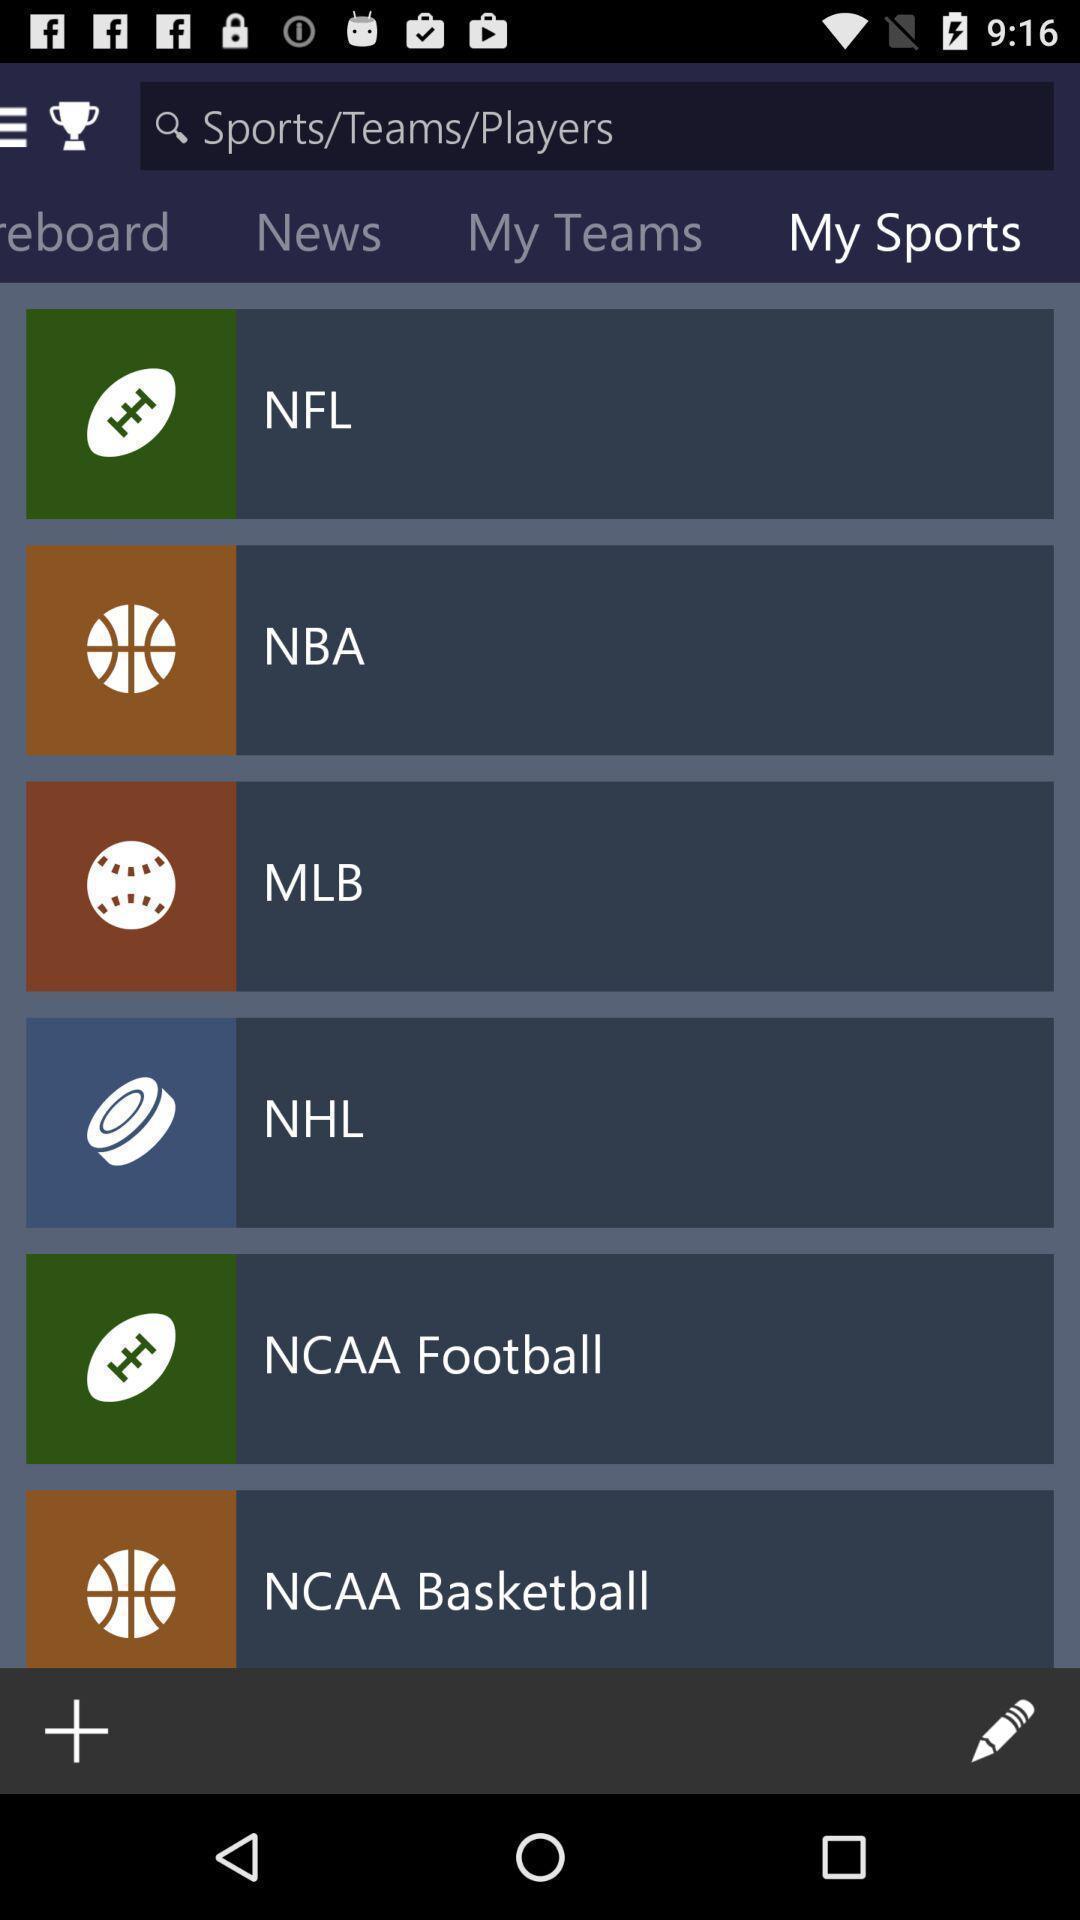Summarize the information in this screenshot. Various league names page displayed in a sports app. 